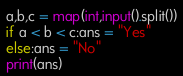<code> <loc_0><loc_0><loc_500><loc_500><_Python_>a,b,c = map(int,input().split())
if a < b < c:ans = "Yes"
else:ans = "No"
print(ans)
</code> 